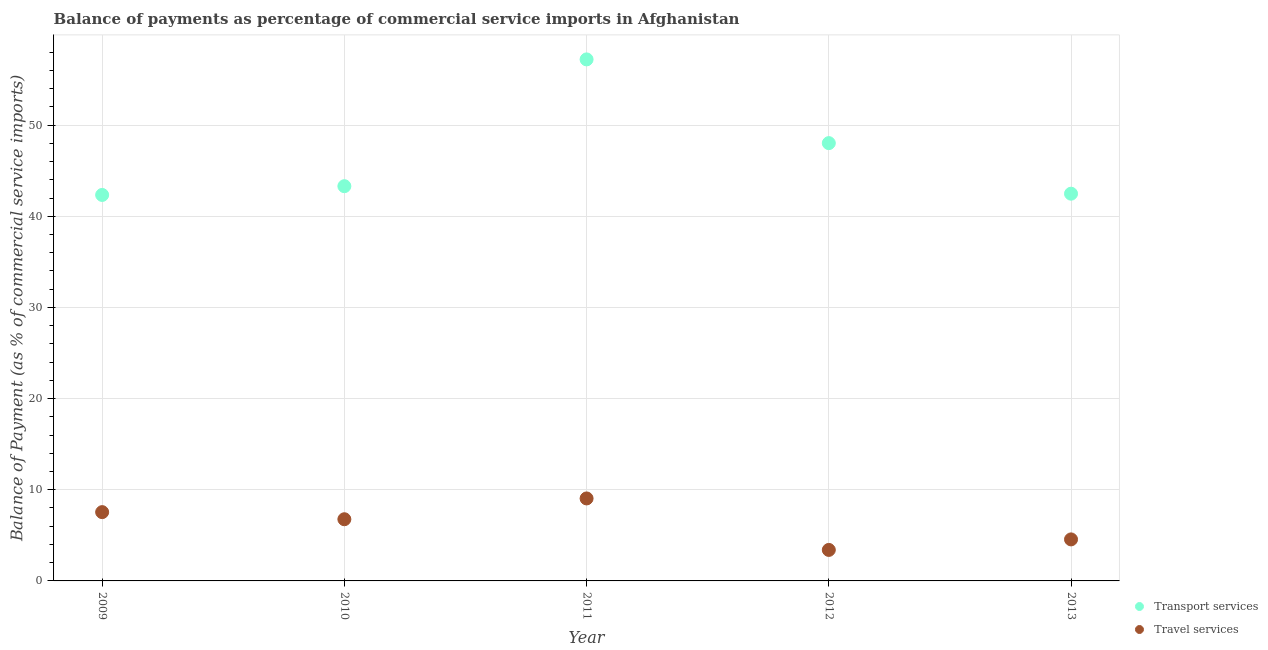How many different coloured dotlines are there?
Provide a short and direct response. 2. What is the balance of payments of travel services in 2013?
Ensure brevity in your answer.  4.56. Across all years, what is the maximum balance of payments of transport services?
Provide a short and direct response. 57.21. Across all years, what is the minimum balance of payments of transport services?
Your answer should be compact. 42.34. What is the total balance of payments of travel services in the graph?
Ensure brevity in your answer.  31.32. What is the difference between the balance of payments of transport services in 2012 and that in 2013?
Offer a very short reply. 5.55. What is the difference between the balance of payments of travel services in 2011 and the balance of payments of transport services in 2013?
Give a very brief answer. -33.43. What is the average balance of payments of travel services per year?
Your response must be concise. 6.26. In the year 2013, what is the difference between the balance of payments of transport services and balance of payments of travel services?
Your response must be concise. 37.92. In how many years, is the balance of payments of transport services greater than 52 %?
Your answer should be compact. 1. What is the ratio of the balance of payments of transport services in 2009 to that in 2012?
Your response must be concise. 0.88. Is the balance of payments of transport services in 2009 less than that in 2010?
Give a very brief answer. Yes. Is the difference between the balance of payments of transport services in 2009 and 2011 greater than the difference between the balance of payments of travel services in 2009 and 2011?
Provide a short and direct response. No. What is the difference between the highest and the second highest balance of payments of transport services?
Offer a terse response. 9.18. What is the difference between the highest and the lowest balance of payments of transport services?
Your answer should be very brief. 14.87. In how many years, is the balance of payments of travel services greater than the average balance of payments of travel services taken over all years?
Your response must be concise. 3. Does the balance of payments of transport services monotonically increase over the years?
Ensure brevity in your answer.  No. What is the difference between two consecutive major ticks on the Y-axis?
Offer a very short reply. 10. Does the graph contain grids?
Your answer should be very brief. Yes. Where does the legend appear in the graph?
Keep it short and to the point. Bottom right. How many legend labels are there?
Your response must be concise. 2. How are the legend labels stacked?
Give a very brief answer. Vertical. What is the title of the graph?
Keep it short and to the point. Balance of payments as percentage of commercial service imports in Afghanistan. What is the label or title of the X-axis?
Your answer should be very brief. Year. What is the label or title of the Y-axis?
Make the answer very short. Balance of Payment (as % of commercial service imports). What is the Balance of Payment (as % of commercial service imports) of Transport services in 2009?
Keep it short and to the point. 42.34. What is the Balance of Payment (as % of commercial service imports) of Travel services in 2009?
Your answer should be very brief. 7.55. What is the Balance of Payment (as % of commercial service imports) of Transport services in 2010?
Provide a succinct answer. 43.3. What is the Balance of Payment (as % of commercial service imports) in Travel services in 2010?
Give a very brief answer. 6.77. What is the Balance of Payment (as % of commercial service imports) in Transport services in 2011?
Provide a short and direct response. 57.21. What is the Balance of Payment (as % of commercial service imports) of Travel services in 2011?
Keep it short and to the point. 9.05. What is the Balance of Payment (as % of commercial service imports) in Transport services in 2012?
Your answer should be very brief. 48.02. What is the Balance of Payment (as % of commercial service imports) of Travel services in 2012?
Your response must be concise. 3.4. What is the Balance of Payment (as % of commercial service imports) in Transport services in 2013?
Your answer should be compact. 42.48. What is the Balance of Payment (as % of commercial service imports) of Travel services in 2013?
Give a very brief answer. 4.56. Across all years, what is the maximum Balance of Payment (as % of commercial service imports) in Transport services?
Make the answer very short. 57.21. Across all years, what is the maximum Balance of Payment (as % of commercial service imports) of Travel services?
Your response must be concise. 9.05. Across all years, what is the minimum Balance of Payment (as % of commercial service imports) in Transport services?
Give a very brief answer. 42.34. Across all years, what is the minimum Balance of Payment (as % of commercial service imports) of Travel services?
Your response must be concise. 3.4. What is the total Balance of Payment (as % of commercial service imports) in Transport services in the graph?
Offer a very short reply. 233.35. What is the total Balance of Payment (as % of commercial service imports) in Travel services in the graph?
Ensure brevity in your answer.  31.32. What is the difference between the Balance of Payment (as % of commercial service imports) in Transport services in 2009 and that in 2010?
Offer a very short reply. -0.96. What is the difference between the Balance of Payment (as % of commercial service imports) in Travel services in 2009 and that in 2010?
Ensure brevity in your answer.  0.78. What is the difference between the Balance of Payment (as % of commercial service imports) of Transport services in 2009 and that in 2011?
Provide a succinct answer. -14.87. What is the difference between the Balance of Payment (as % of commercial service imports) of Travel services in 2009 and that in 2011?
Give a very brief answer. -1.5. What is the difference between the Balance of Payment (as % of commercial service imports) of Transport services in 2009 and that in 2012?
Provide a short and direct response. -5.68. What is the difference between the Balance of Payment (as % of commercial service imports) in Travel services in 2009 and that in 2012?
Provide a succinct answer. 4.15. What is the difference between the Balance of Payment (as % of commercial service imports) in Transport services in 2009 and that in 2013?
Keep it short and to the point. -0.14. What is the difference between the Balance of Payment (as % of commercial service imports) of Travel services in 2009 and that in 2013?
Your response must be concise. 2.99. What is the difference between the Balance of Payment (as % of commercial service imports) in Transport services in 2010 and that in 2011?
Offer a very short reply. -13.91. What is the difference between the Balance of Payment (as % of commercial service imports) in Travel services in 2010 and that in 2011?
Your answer should be very brief. -2.28. What is the difference between the Balance of Payment (as % of commercial service imports) of Transport services in 2010 and that in 2012?
Your response must be concise. -4.72. What is the difference between the Balance of Payment (as % of commercial service imports) of Travel services in 2010 and that in 2012?
Make the answer very short. 3.37. What is the difference between the Balance of Payment (as % of commercial service imports) in Transport services in 2010 and that in 2013?
Your answer should be very brief. 0.82. What is the difference between the Balance of Payment (as % of commercial service imports) of Travel services in 2010 and that in 2013?
Keep it short and to the point. 2.21. What is the difference between the Balance of Payment (as % of commercial service imports) of Transport services in 2011 and that in 2012?
Keep it short and to the point. 9.18. What is the difference between the Balance of Payment (as % of commercial service imports) of Travel services in 2011 and that in 2012?
Offer a very short reply. 5.65. What is the difference between the Balance of Payment (as % of commercial service imports) of Transport services in 2011 and that in 2013?
Your response must be concise. 14.73. What is the difference between the Balance of Payment (as % of commercial service imports) in Travel services in 2011 and that in 2013?
Provide a short and direct response. 4.49. What is the difference between the Balance of Payment (as % of commercial service imports) of Transport services in 2012 and that in 2013?
Make the answer very short. 5.55. What is the difference between the Balance of Payment (as % of commercial service imports) of Travel services in 2012 and that in 2013?
Keep it short and to the point. -1.15. What is the difference between the Balance of Payment (as % of commercial service imports) of Transport services in 2009 and the Balance of Payment (as % of commercial service imports) of Travel services in 2010?
Keep it short and to the point. 35.57. What is the difference between the Balance of Payment (as % of commercial service imports) in Transport services in 2009 and the Balance of Payment (as % of commercial service imports) in Travel services in 2011?
Make the answer very short. 33.29. What is the difference between the Balance of Payment (as % of commercial service imports) of Transport services in 2009 and the Balance of Payment (as % of commercial service imports) of Travel services in 2012?
Offer a very short reply. 38.94. What is the difference between the Balance of Payment (as % of commercial service imports) in Transport services in 2009 and the Balance of Payment (as % of commercial service imports) in Travel services in 2013?
Your answer should be compact. 37.78. What is the difference between the Balance of Payment (as % of commercial service imports) of Transport services in 2010 and the Balance of Payment (as % of commercial service imports) of Travel services in 2011?
Make the answer very short. 34.25. What is the difference between the Balance of Payment (as % of commercial service imports) of Transport services in 2010 and the Balance of Payment (as % of commercial service imports) of Travel services in 2012?
Give a very brief answer. 39.9. What is the difference between the Balance of Payment (as % of commercial service imports) of Transport services in 2010 and the Balance of Payment (as % of commercial service imports) of Travel services in 2013?
Provide a short and direct response. 38.75. What is the difference between the Balance of Payment (as % of commercial service imports) in Transport services in 2011 and the Balance of Payment (as % of commercial service imports) in Travel services in 2012?
Offer a very short reply. 53.81. What is the difference between the Balance of Payment (as % of commercial service imports) in Transport services in 2011 and the Balance of Payment (as % of commercial service imports) in Travel services in 2013?
Offer a very short reply. 52.65. What is the difference between the Balance of Payment (as % of commercial service imports) of Transport services in 2012 and the Balance of Payment (as % of commercial service imports) of Travel services in 2013?
Your answer should be very brief. 43.47. What is the average Balance of Payment (as % of commercial service imports) in Transport services per year?
Ensure brevity in your answer.  46.67. What is the average Balance of Payment (as % of commercial service imports) of Travel services per year?
Offer a terse response. 6.26. In the year 2009, what is the difference between the Balance of Payment (as % of commercial service imports) of Transport services and Balance of Payment (as % of commercial service imports) of Travel services?
Provide a short and direct response. 34.79. In the year 2010, what is the difference between the Balance of Payment (as % of commercial service imports) of Transport services and Balance of Payment (as % of commercial service imports) of Travel services?
Give a very brief answer. 36.53. In the year 2011, what is the difference between the Balance of Payment (as % of commercial service imports) in Transport services and Balance of Payment (as % of commercial service imports) in Travel services?
Keep it short and to the point. 48.16. In the year 2012, what is the difference between the Balance of Payment (as % of commercial service imports) of Transport services and Balance of Payment (as % of commercial service imports) of Travel services?
Offer a terse response. 44.62. In the year 2013, what is the difference between the Balance of Payment (as % of commercial service imports) of Transport services and Balance of Payment (as % of commercial service imports) of Travel services?
Offer a terse response. 37.92. What is the ratio of the Balance of Payment (as % of commercial service imports) in Transport services in 2009 to that in 2010?
Offer a very short reply. 0.98. What is the ratio of the Balance of Payment (as % of commercial service imports) of Travel services in 2009 to that in 2010?
Your answer should be very brief. 1.12. What is the ratio of the Balance of Payment (as % of commercial service imports) of Transport services in 2009 to that in 2011?
Give a very brief answer. 0.74. What is the ratio of the Balance of Payment (as % of commercial service imports) of Travel services in 2009 to that in 2011?
Offer a terse response. 0.83. What is the ratio of the Balance of Payment (as % of commercial service imports) of Transport services in 2009 to that in 2012?
Offer a very short reply. 0.88. What is the ratio of the Balance of Payment (as % of commercial service imports) in Travel services in 2009 to that in 2012?
Give a very brief answer. 2.22. What is the ratio of the Balance of Payment (as % of commercial service imports) in Transport services in 2009 to that in 2013?
Your answer should be very brief. 1. What is the ratio of the Balance of Payment (as % of commercial service imports) in Travel services in 2009 to that in 2013?
Your response must be concise. 1.66. What is the ratio of the Balance of Payment (as % of commercial service imports) in Transport services in 2010 to that in 2011?
Provide a succinct answer. 0.76. What is the ratio of the Balance of Payment (as % of commercial service imports) in Travel services in 2010 to that in 2011?
Make the answer very short. 0.75. What is the ratio of the Balance of Payment (as % of commercial service imports) in Transport services in 2010 to that in 2012?
Your response must be concise. 0.9. What is the ratio of the Balance of Payment (as % of commercial service imports) of Travel services in 2010 to that in 2012?
Your answer should be very brief. 1.99. What is the ratio of the Balance of Payment (as % of commercial service imports) in Transport services in 2010 to that in 2013?
Make the answer very short. 1.02. What is the ratio of the Balance of Payment (as % of commercial service imports) in Travel services in 2010 to that in 2013?
Your answer should be very brief. 1.49. What is the ratio of the Balance of Payment (as % of commercial service imports) in Transport services in 2011 to that in 2012?
Give a very brief answer. 1.19. What is the ratio of the Balance of Payment (as % of commercial service imports) in Travel services in 2011 to that in 2012?
Make the answer very short. 2.66. What is the ratio of the Balance of Payment (as % of commercial service imports) of Transport services in 2011 to that in 2013?
Offer a terse response. 1.35. What is the ratio of the Balance of Payment (as % of commercial service imports) in Travel services in 2011 to that in 2013?
Your answer should be very brief. 1.99. What is the ratio of the Balance of Payment (as % of commercial service imports) of Transport services in 2012 to that in 2013?
Your answer should be very brief. 1.13. What is the ratio of the Balance of Payment (as % of commercial service imports) in Travel services in 2012 to that in 2013?
Keep it short and to the point. 0.75. What is the difference between the highest and the second highest Balance of Payment (as % of commercial service imports) of Transport services?
Offer a very short reply. 9.18. What is the difference between the highest and the second highest Balance of Payment (as % of commercial service imports) in Travel services?
Give a very brief answer. 1.5. What is the difference between the highest and the lowest Balance of Payment (as % of commercial service imports) of Transport services?
Make the answer very short. 14.87. What is the difference between the highest and the lowest Balance of Payment (as % of commercial service imports) of Travel services?
Make the answer very short. 5.65. 